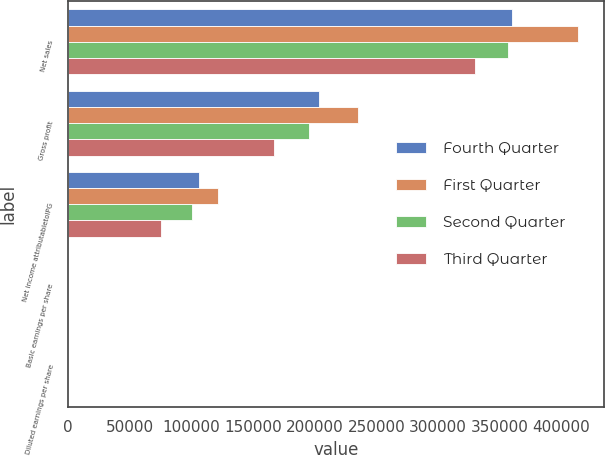<chart> <loc_0><loc_0><loc_500><loc_500><stacked_bar_chart><ecel><fcel>Net sales<fcel>Gross profit<fcel>Net income attributabletoIPG<fcel>Basic earnings per share<fcel>Diluted earnings per share<nl><fcel>Fourth Quarter<fcel>359864<fcel>203362<fcel>106334<fcel>1.98<fcel>1.93<nl><fcel>First Quarter<fcel>413613<fcel>234975<fcel>121617<fcel>2.27<fcel>2.21<nl><fcel>Second Quarter<fcel>356346<fcel>195184<fcel>100517<fcel>1.88<fcel>1.84<nl><fcel>Third Quarter<fcel>330051<fcel>166747<fcel>75559<fcel>1.42<fcel>1.4<nl></chart> 